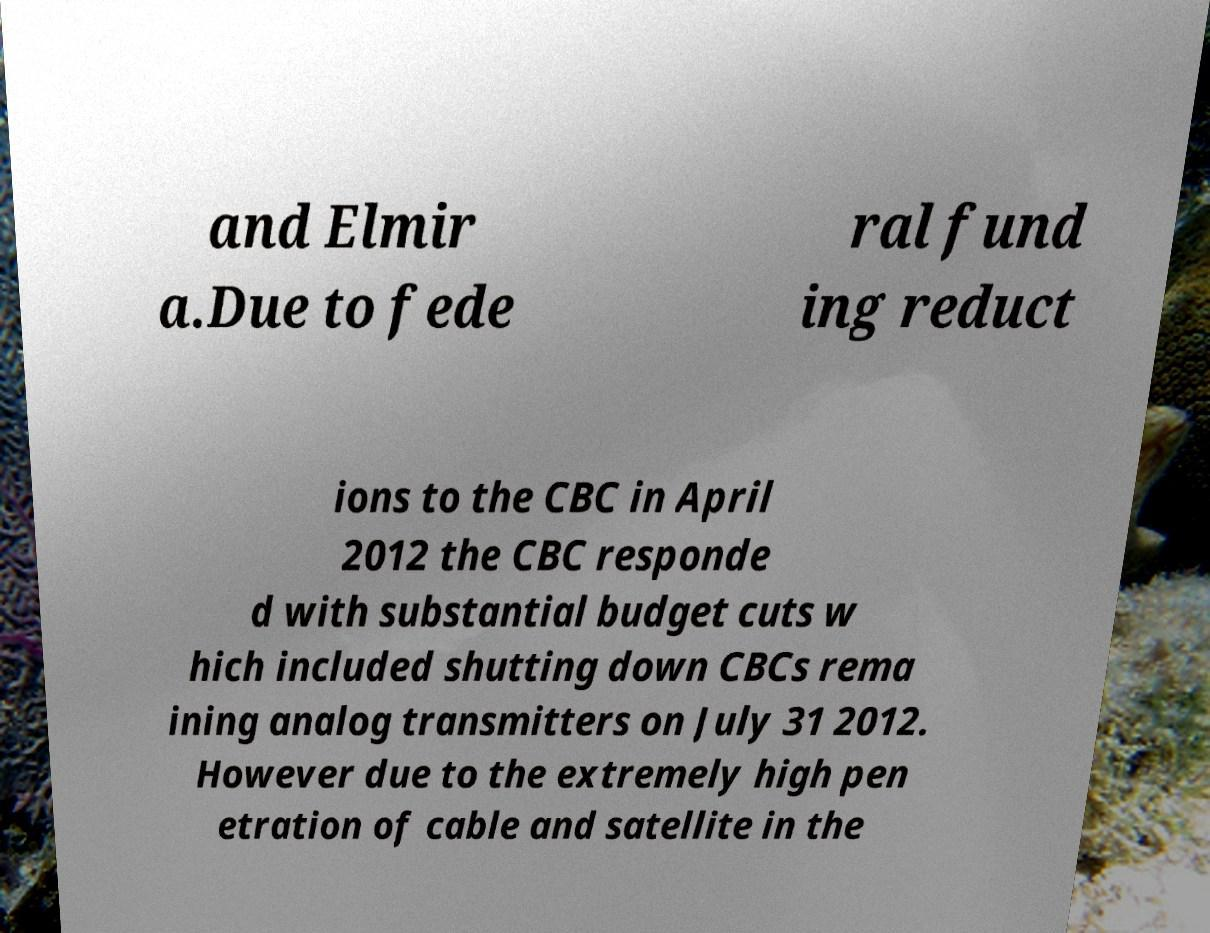Could you extract and type out the text from this image? and Elmir a.Due to fede ral fund ing reduct ions to the CBC in April 2012 the CBC responde d with substantial budget cuts w hich included shutting down CBCs rema ining analog transmitters on July 31 2012. However due to the extremely high pen etration of cable and satellite in the 